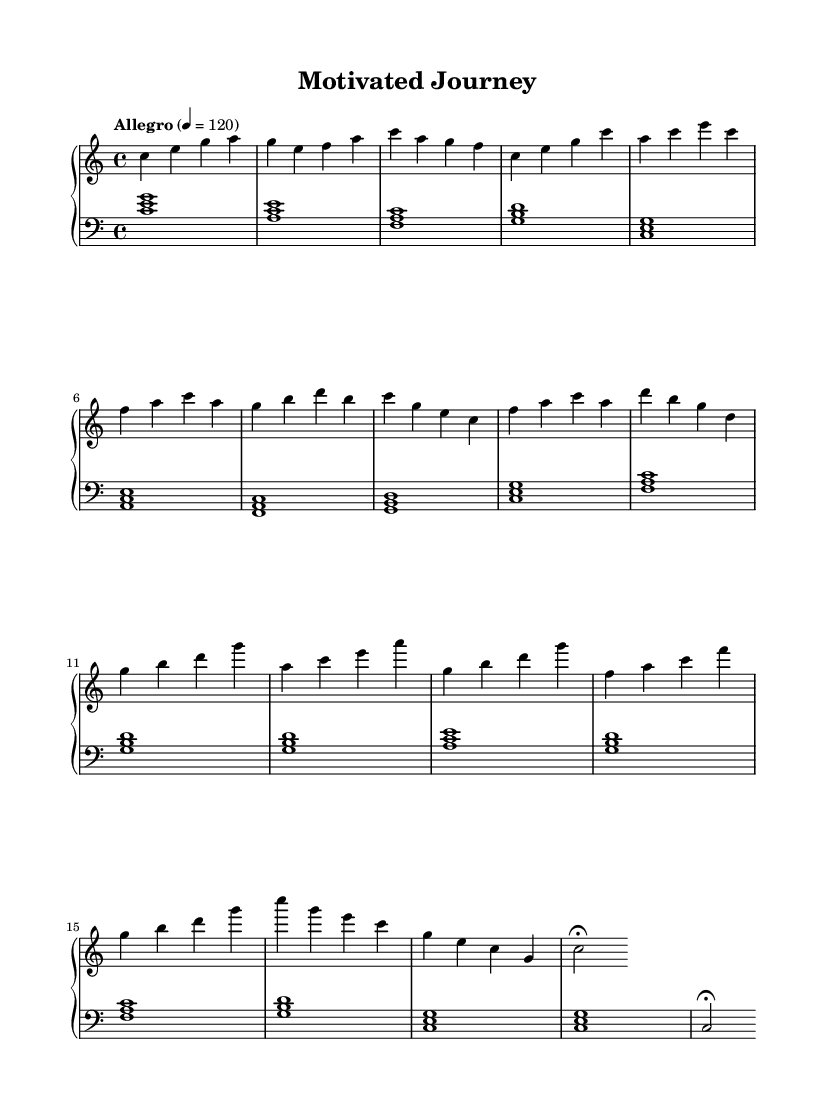What is the key signature of this music? The key signature is C major, which is indicated by the absence of any sharps or flats at the beginning of the staff.
Answer: C major What is the time signature of this music? The time signature is indicated at the beginning of the sheet music as 4/4, meaning there are four beats in each measure and the quarter note gets one beat.
Answer: 4/4 What is the tempo marking of this music? The tempo marking states "Allegro" with a metronome marking of 120, suggesting a fast tempo, typically around 120 beats per minute.
Answer: Allegro 4 = 120 How many sections are in the composition? By analyzing the structure presented in the sheet music, the sections include an Intro, Verse, Chorus, Bridge, and Outro, which totals five distinct sections.
Answer: 5 What is the first chord played in the piece? The first chord presented in the sheet music is a C major chord, which consists of the notes C, E, and G played together.
Answer: C major Which measure does the Chorus start? The Chorus starts in measure 7, following the Verse and transitioning to the next section based on the layout of the measures in the music.
Answer: Measure 7 What is the last note in the music? The last note in the music is a C note which is held for a longer duration, noted by the fermata, signifying it should be sustained.
Answer: C 